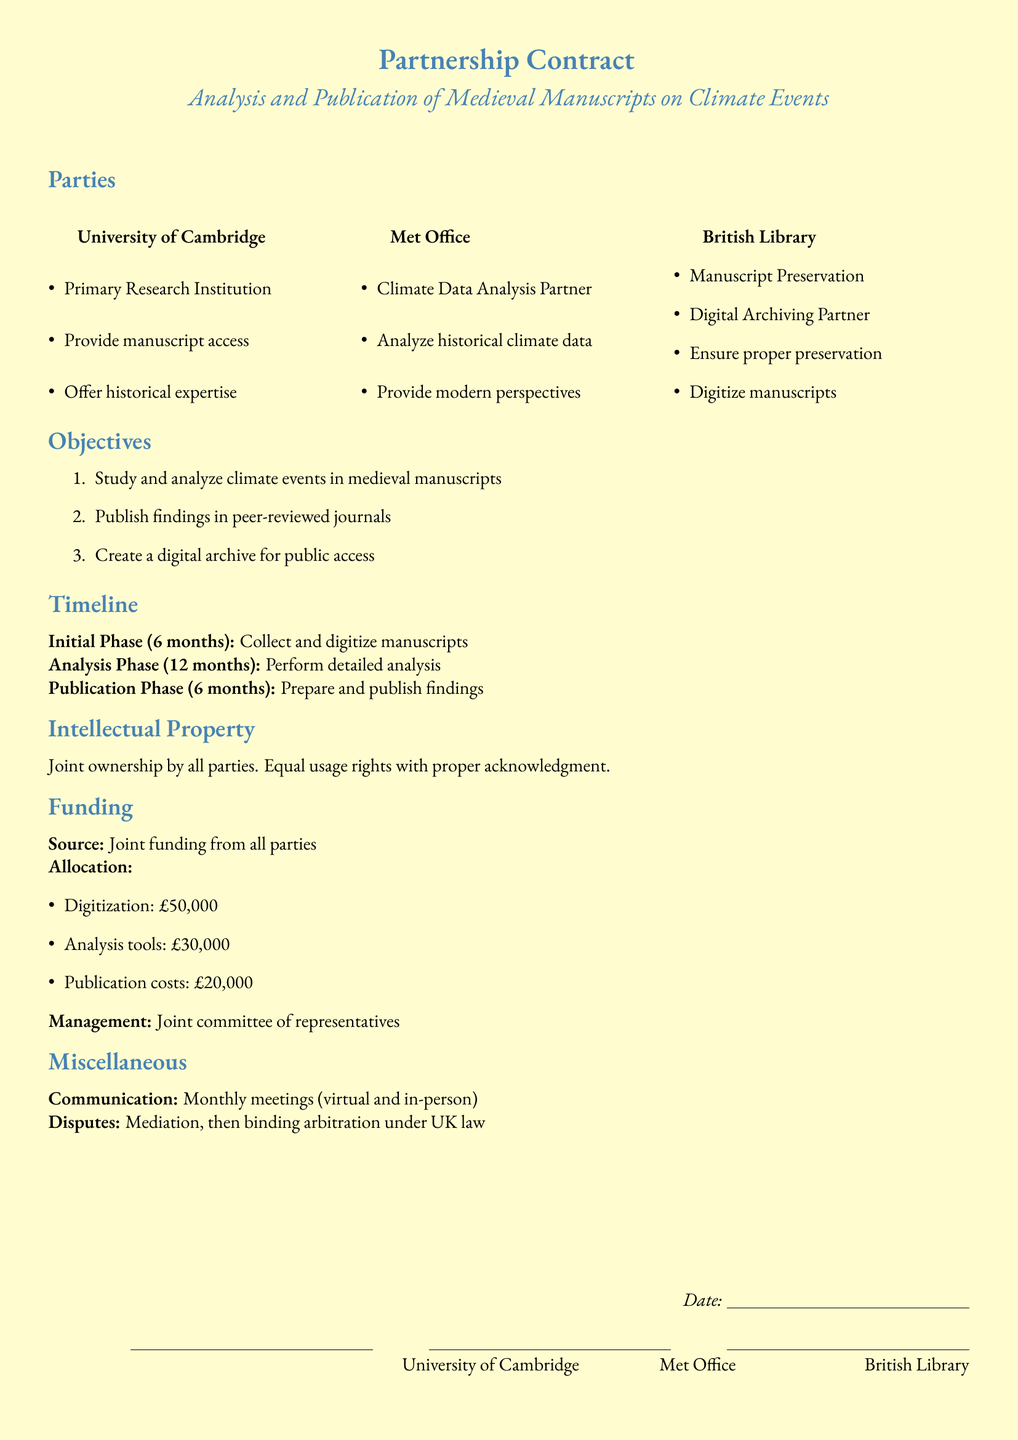What is the title of the contract? The title of the contract can be found at the top of the document, which describes the main focus of the agreement.
Answer: Partnership Contract Who are the primary parties involved? The primary parties are listed under the "Parties" section of the document, highlighting their roles in the partnership.
Answer: University of Cambridge, Met Office, British Library What is the funding allocation for digitization? The funding allocation is specified in the "Funding" section, detailing the amounts allocated for specific purposes.
Answer: £50,000 How long is the Initial Phase? The duration of the Initial Phase is mentioned within the "Timeline" section, indicating the time set for manuscript collection and digitization.
Answer: 6 months What is the main objective of the partnership? The objectives of the partnership are outlined in the "Objectives" section, summarizing the main goals of the collaboration.
Answer: Study and analyze climate events in medieval manuscripts How will disputes be resolved? The process for resolving disputes is mentioned towards the end of the document, explaining the mediation and arbitration methods to be used.
Answer: Mediation, then binding arbitration under UK law What is the duration of the Publication Phase? The duration of the Publication Phase is noted in the "Timeline" section, providing information on how long this phase will take.
Answer: 6 months What type of ownership is specified for intellectual property? The "Intellectual Property" section outlines the ownership structure concerning the project's outcomes.
Answer: Joint ownership by all parties 